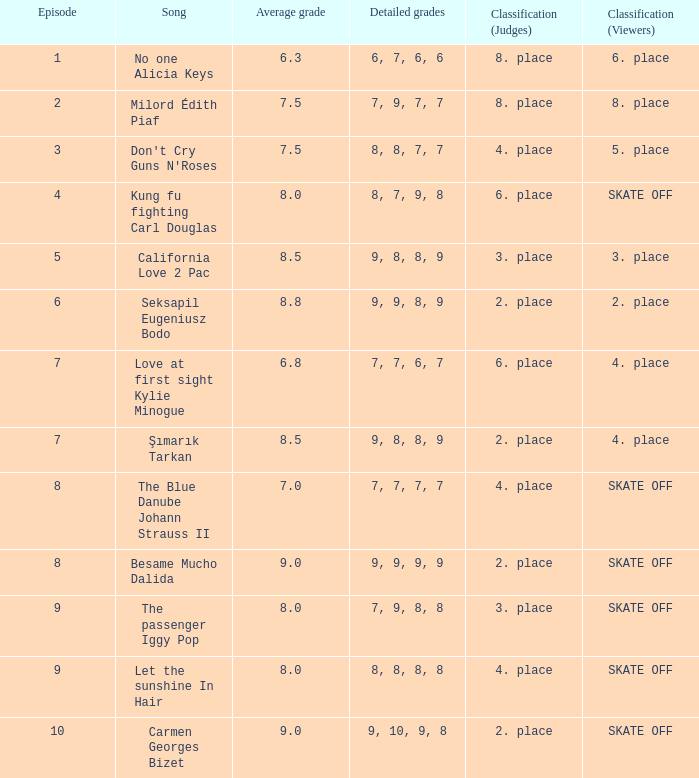Determine the group for these numbers: 9, 9, 8, 9. 2. place. 